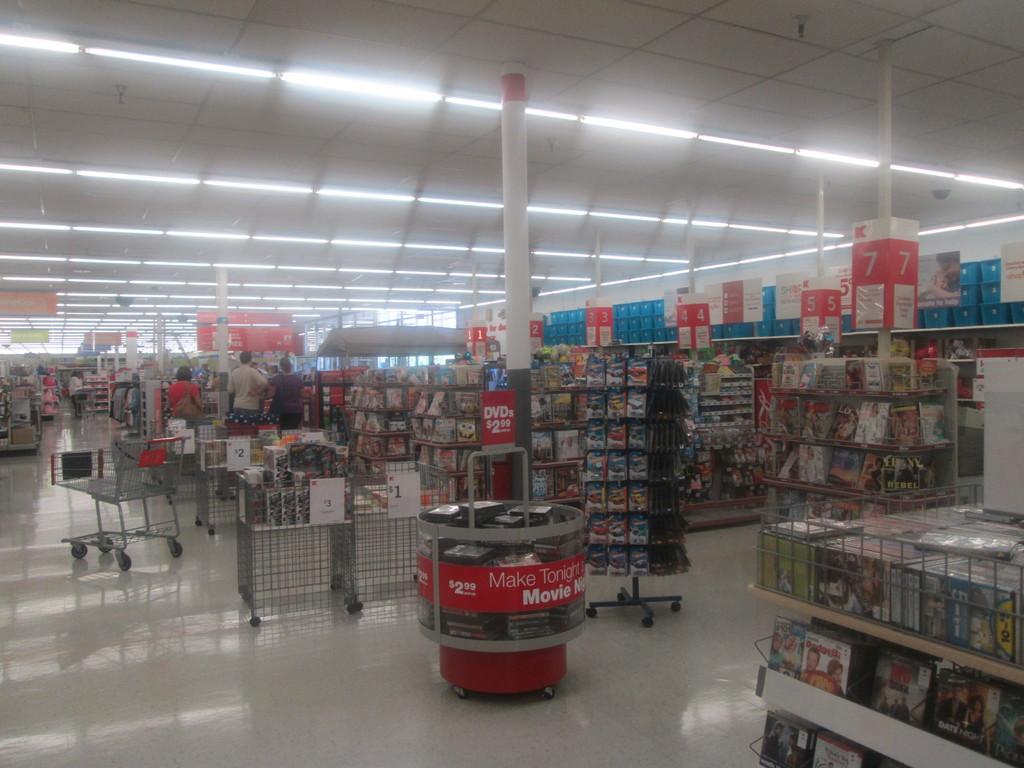What store is this?
Provide a succinct answer. Unanswerable. How much do the dvds cost?
Offer a terse response. 2.99. 